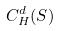Convert formula to latex. <formula><loc_0><loc_0><loc_500><loc_500>C _ { H } ^ { d } ( S )</formula> 